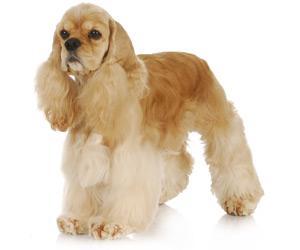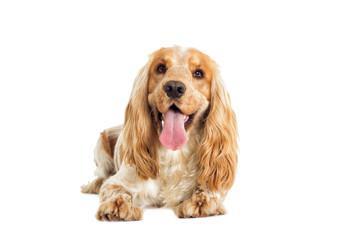The first image is the image on the left, the second image is the image on the right. Examine the images to the left and right. Is the description "The dog in the image on the left is standing on all fours." accurate? Answer yes or no. Yes. 